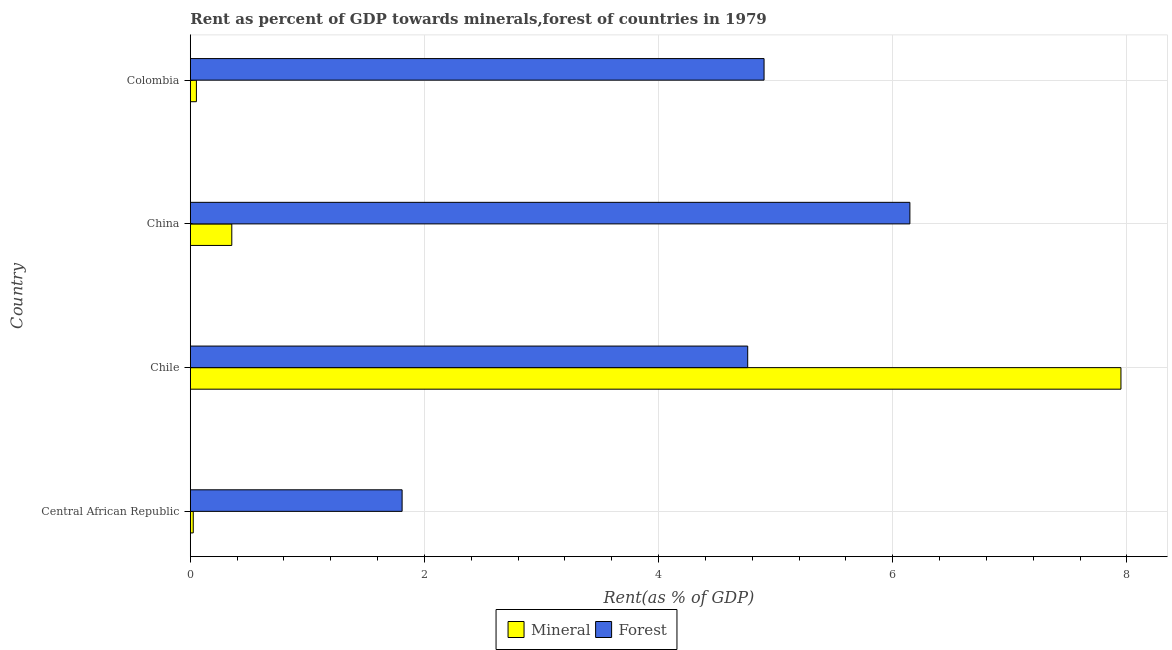Are the number of bars per tick equal to the number of legend labels?
Provide a succinct answer. Yes. How many bars are there on the 2nd tick from the top?
Your answer should be compact. 2. In how many cases, is the number of bars for a given country not equal to the number of legend labels?
Offer a terse response. 0. What is the forest rent in Central African Republic?
Keep it short and to the point. 1.81. Across all countries, what is the maximum mineral rent?
Provide a succinct answer. 7.95. Across all countries, what is the minimum forest rent?
Offer a very short reply. 1.81. In which country was the mineral rent maximum?
Make the answer very short. Chile. In which country was the forest rent minimum?
Provide a succinct answer. Central African Republic. What is the total forest rent in the graph?
Give a very brief answer. 17.62. What is the difference between the forest rent in Central African Republic and that in China?
Your response must be concise. -4.34. What is the difference between the mineral rent in Colombia and the forest rent in Central African Republic?
Ensure brevity in your answer.  -1.76. What is the average forest rent per country?
Your answer should be compact. 4.41. What is the difference between the forest rent and mineral rent in Colombia?
Make the answer very short. 4.85. In how many countries, is the mineral rent greater than 1.2000000000000002 %?
Offer a terse response. 1. What is the ratio of the mineral rent in Central African Republic to that in China?
Give a very brief answer. 0.07. What is the difference between the highest and the second highest forest rent?
Provide a succinct answer. 1.25. What is the difference between the highest and the lowest forest rent?
Ensure brevity in your answer.  4.34. In how many countries, is the forest rent greater than the average forest rent taken over all countries?
Offer a terse response. 3. Is the sum of the forest rent in Central African Republic and China greater than the maximum mineral rent across all countries?
Your response must be concise. Yes. What does the 2nd bar from the top in Colombia represents?
Provide a short and direct response. Mineral. What does the 1st bar from the bottom in Chile represents?
Your answer should be compact. Mineral. Are all the bars in the graph horizontal?
Your answer should be compact. Yes. Does the graph contain any zero values?
Make the answer very short. No. Does the graph contain grids?
Your answer should be very brief. Yes. What is the title of the graph?
Provide a succinct answer. Rent as percent of GDP towards minerals,forest of countries in 1979. Does "Residents" appear as one of the legend labels in the graph?
Provide a succinct answer. No. What is the label or title of the X-axis?
Your answer should be very brief. Rent(as % of GDP). What is the Rent(as % of GDP) in Mineral in Central African Republic?
Your response must be concise. 0.03. What is the Rent(as % of GDP) of Forest in Central African Republic?
Your answer should be compact. 1.81. What is the Rent(as % of GDP) in Mineral in Chile?
Give a very brief answer. 7.95. What is the Rent(as % of GDP) of Forest in Chile?
Provide a short and direct response. 4.76. What is the Rent(as % of GDP) in Mineral in China?
Your answer should be very brief. 0.35. What is the Rent(as % of GDP) of Forest in China?
Provide a short and direct response. 6.15. What is the Rent(as % of GDP) of Mineral in Colombia?
Provide a succinct answer. 0.05. What is the Rent(as % of GDP) in Forest in Colombia?
Make the answer very short. 4.9. Across all countries, what is the maximum Rent(as % of GDP) in Mineral?
Make the answer very short. 7.95. Across all countries, what is the maximum Rent(as % of GDP) in Forest?
Give a very brief answer. 6.15. Across all countries, what is the minimum Rent(as % of GDP) in Mineral?
Your answer should be compact. 0.03. Across all countries, what is the minimum Rent(as % of GDP) of Forest?
Offer a terse response. 1.81. What is the total Rent(as % of GDP) of Mineral in the graph?
Your answer should be very brief. 8.38. What is the total Rent(as % of GDP) in Forest in the graph?
Your answer should be compact. 17.62. What is the difference between the Rent(as % of GDP) in Mineral in Central African Republic and that in Chile?
Make the answer very short. -7.92. What is the difference between the Rent(as % of GDP) in Forest in Central African Republic and that in Chile?
Keep it short and to the point. -2.95. What is the difference between the Rent(as % of GDP) of Mineral in Central African Republic and that in China?
Provide a succinct answer. -0.33. What is the difference between the Rent(as % of GDP) in Forest in Central African Republic and that in China?
Ensure brevity in your answer.  -4.34. What is the difference between the Rent(as % of GDP) in Mineral in Central African Republic and that in Colombia?
Your answer should be very brief. -0.03. What is the difference between the Rent(as % of GDP) in Forest in Central African Republic and that in Colombia?
Keep it short and to the point. -3.09. What is the difference between the Rent(as % of GDP) in Mineral in Chile and that in China?
Your answer should be compact. 7.6. What is the difference between the Rent(as % of GDP) in Forest in Chile and that in China?
Offer a terse response. -1.39. What is the difference between the Rent(as % of GDP) of Mineral in Chile and that in Colombia?
Make the answer very short. 7.9. What is the difference between the Rent(as % of GDP) of Forest in Chile and that in Colombia?
Your answer should be very brief. -0.14. What is the difference between the Rent(as % of GDP) of Mineral in China and that in Colombia?
Make the answer very short. 0.3. What is the difference between the Rent(as % of GDP) of Forest in China and that in Colombia?
Offer a very short reply. 1.25. What is the difference between the Rent(as % of GDP) of Mineral in Central African Republic and the Rent(as % of GDP) of Forest in Chile?
Your answer should be very brief. -4.74. What is the difference between the Rent(as % of GDP) in Mineral in Central African Republic and the Rent(as % of GDP) in Forest in China?
Provide a succinct answer. -6.12. What is the difference between the Rent(as % of GDP) in Mineral in Central African Republic and the Rent(as % of GDP) in Forest in Colombia?
Your answer should be very brief. -4.88. What is the difference between the Rent(as % of GDP) of Mineral in Chile and the Rent(as % of GDP) of Forest in China?
Offer a terse response. 1.8. What is the difference between the Rent(as % of GDP) of Mineral in Chile and the Rent(as % of GDP) of Forest in Colombia?
Provide a succinct answer. 3.05. What is the difference between the Rent(as % of GDP) of Mineral in China and the Rent(as % of GDP) of Forest in Colombia?
Ensure brevity in your answer.  -4.55. What is the average Rent(as % of GDP) of Mineral per country?
Make the answer very short. 2.1. What is the average Rent(as % of GDP) in Forest per country?
Keep it short and to the point. 4.4. What is the difference between the Rent(as % of GDP) of Mineral and Rent(as % of GDP) of Forest in Central African Republic?
Make the answer very short. -1.78. What is the difference between the Rent(as % of GDP) of Mineral and Rent(as % of GDP) of Forest in Chile?
Your answer should be compact. 3.19. What is the difference between the Rent(as % of GDP) in Mineral and Rent(as % of GDP) in Forest in China?
Provide a short and direct response. -5.79. What is the difference between the Rent(as % of GDP) in Mineral and Rent(as % of GDP) in Forest in Colombia?
Ensure brevity in your answer.  -4.85. What is the ratio of the Rent(as % of GDP) of Mineral in Central African Republic to that in Chile?
Your answer should be very brief. 0. What is the ratio of the Rent(as % of GDP) in Forest in Central African Republic to that in Chile?
Offer a very short reply. 0.38. What is the ratio of the Rent(as % of GDP) in Mineral in Central African Republic to that in China?
Offer a terse response. 0.07. What is the ratio of the Rent(as % of GDP) of Forest in Central African Republic to that in China?
Offer a terse response. 0.29. What is the ratio of the Rent(as % of GDP) in Mineral in Central African Republic to that in Colombia?
Offer a very short reply. 0.48. What is the ratio of the Rent(as % of GDP) of Forest in Central African Republic to that in Colombia?
Ensure brevity in your answer.  0.37. What is the ratio of the Rent(as % of GDP) of Mineral in Chile to that in China?
Ensure brevity in your answer.  22.42. What is the ratio of the Rent(as % of GDP) in Forest in Chile to that in China?
Your answer should be very brief. 0.77. What is the ratio of the Rent(as % of GDP) of Mineral in Chile to that in Colombia?
Your answer should be very brief. 152.18. What is the ratio of the Rent(as % of GDP) of Forest in Chile to that in Colombia?
Ensure brevity in your answer.  0.97. What is the ratio of the Rent(as % of GDP) in Mineral in China to that in Colombia?
Provide a succinct answer. 6.79. What is the ratio of the Rent(as % of GDP) of Forest in China to that in Colombia?
Make the answer very short. 1.25. What is the difference between the highest and the second highest Rent(as % of GDP) in Mineral?
Keep it short and to the point. 7.6. What is the difference between the highest and the second highest Rent(as % of GDP) in Forest?
Provide a succinct answer. 1.25. What is the difference between the highest and the lowest Rent(as % of GDP) of Mineral?
Your response must be concise. 7.92. What is the difference between the highest and the lowest Rent(as % of GDP) in Forest?
Provide a succinct answer. 4.34. 